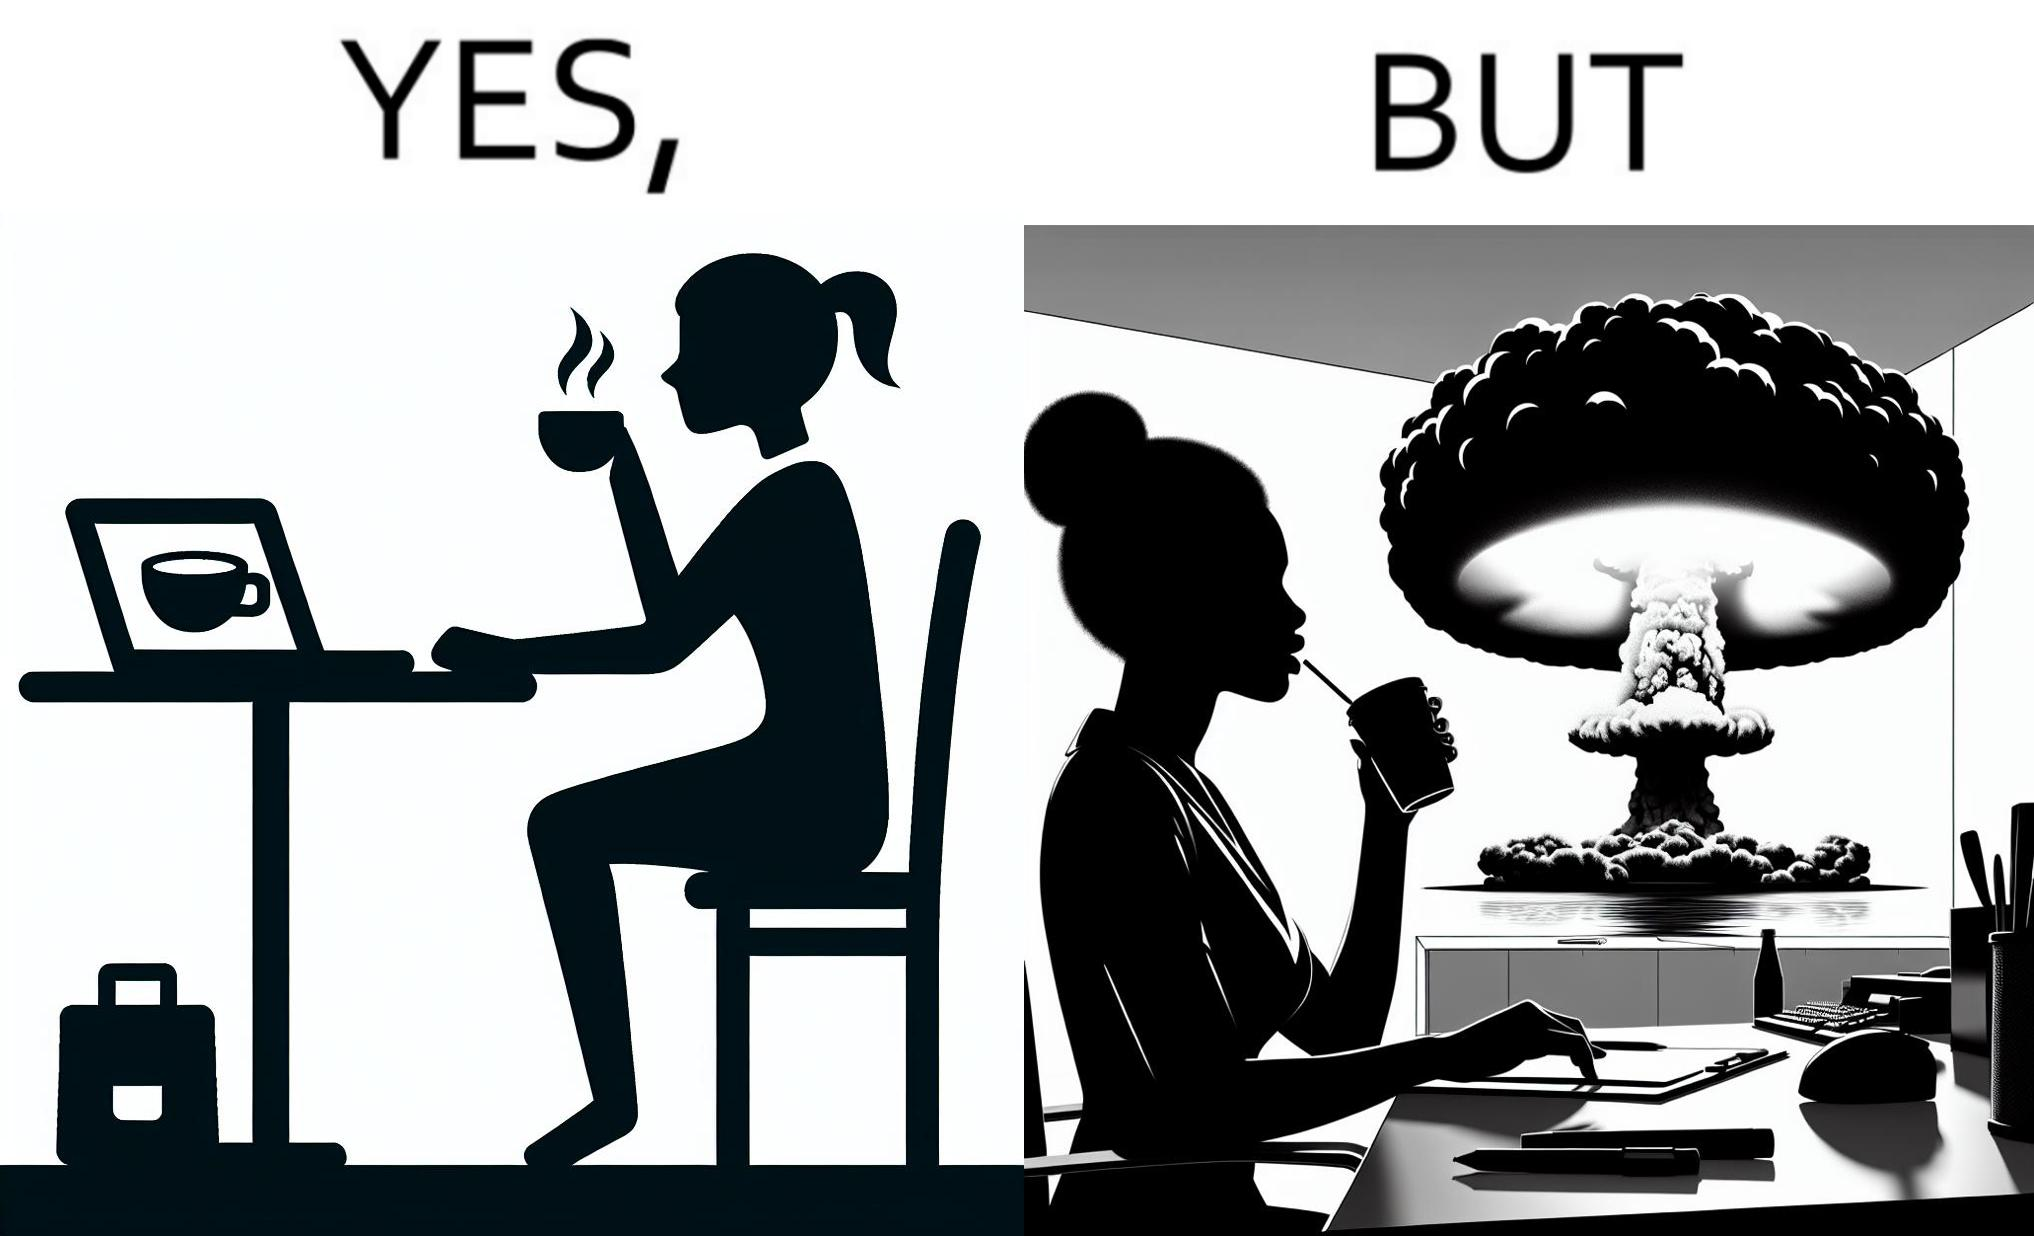What makes this image funny or satirical? The images are funny since it shows a woman simply sipping from a cup at ease in a cafe with her laptop not caring about anything going on outside the cafe even though the situation is very grave,that is, a nuclear blast 